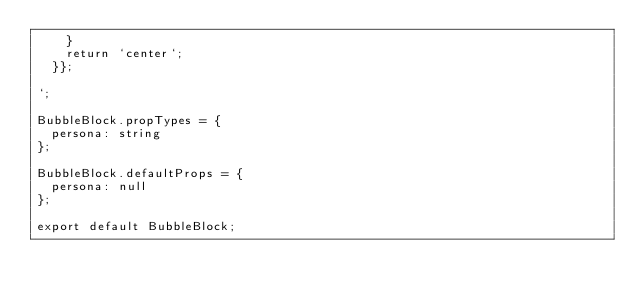<code> <loc_0><loc_0><loc_500><loc_500><_JavaScript_>    }
    return `center`;
  }};

`;

BubbleBlock.propTypes = {
  persona: string
};

BubbleBlock.defaultProps = {
  persona: null
};

export default BubbleBlock;
</code> 